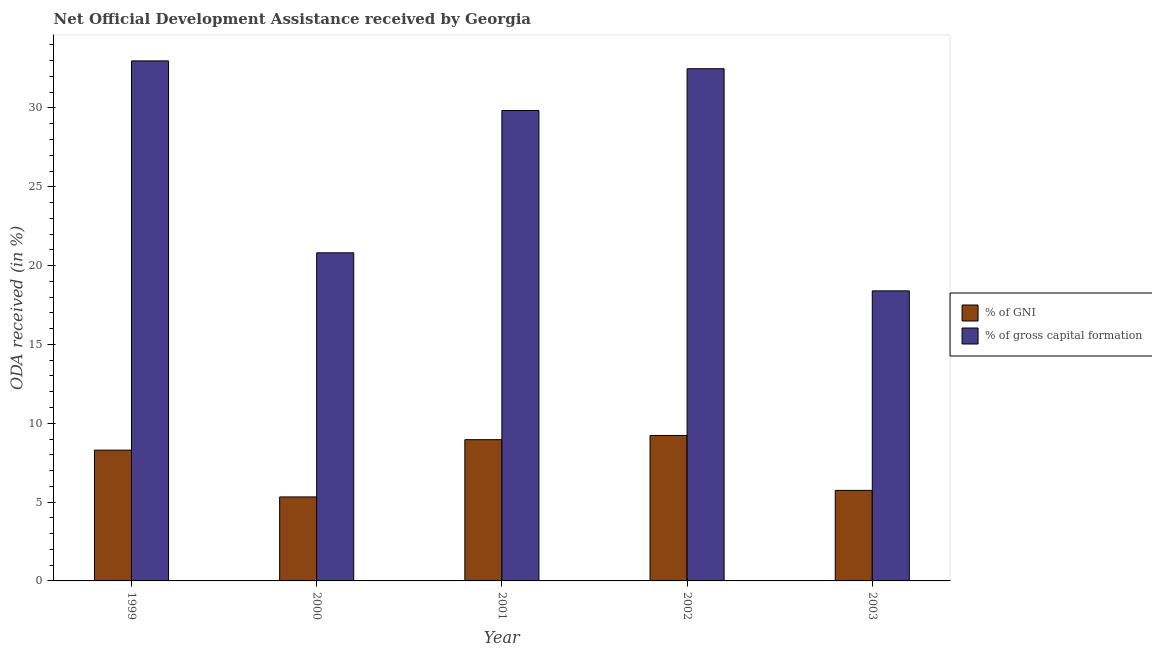How many groups of bars are there?
Provide a succinct answer. 5. Are the number of bars per tick equal to the number of legend labels?
Provide a short and direct response. Yes. How many bars are there on the 3rd tick from the left?
Your answer should be compact. 2. What is the oda received as percentage of gross capital formation in 1999?
Give a very brief answer. 32.99. Across all years, what is the maximum oda received as percentage of gni?
Offer a terse response. 9.23. Across all years, what is the minimum oda received as percentage of gni?
Make the answer very short. 5.33. In which year was the oda received as percentage of gni maximum?
Your response must be concise. 2002. What is the total oda received as percentage of gni in the graph?
Offer a very short reply. 37.55. What is the difference between the oda received as percentage of gross capital formation in 1999 and that in 2001?
Give a very brief answer. 3.15. What is the difference between the oda received as percentage of gni in 2001 and the oda received as percentage of gross capital formation in 1999?
Give a very brief answer. 0.66. What is the average oda received as percentage of gross capital formation per year?
Make the answer very short. 26.91. In the year 2003, what is the difference between the oda received as percentage of gross capital formation and oda received as percentage of gni?
Provide a short and direct response. 0. What is the ratio of the oda received as percentage of gross capital formation in 1999 to that in 2000?
Your answer should be very brief. 1.58. Is the oda received as percentage of gni in 1999 less than that in 2001?
Give a very brief answer. Yes. What is the difference between the highest and the second highest oda received as percentage of gni?
Your response must be concise. 0.27. What is the difference between the highest and the lowest oda received as percentage of gni?
Provide a short and direct response. 3.9. What does the 2nd bar from the left in 2001 represents?
Keep it short and to the point. % of gross capital formation. What does the 2nd bar from the right in 2003 represents?
Your response must be concise. % of GNI. What is the difference between two consecutive major ticks on the Y-axis?
Make the answer very short. 5. Are the values on the major ticks of Y-axis written in scientific E-notation?
Give a very brief answer. No. Does the graph contain any zero values?
Offer a very short reply. No. Does the graph contain grids?
Keep it short and to the point. No. Where does the legend appear in the graph?
Your answer should be very brief. Center right. How many legend labels are there?
Provide a succinct answer. 2. How are the legend labels stacked?
Keep it short and to the point. Vertical. What is the title of the graph?
Offer a very short reply. Net Official Development Assistance received by Georgia. Does "Excluding technical cooperation" appear as one of the legend labels in the graph?
Make the answer very short. No. What is the label or title of the Y-axis?
Keep it short and to the point. ODA received (in %). What is the ODA received (in %) of % of GNI in 1999?
Your response must be concise. 8.3. What is the ODA received (in %) of % of gross capital formation in 1999?
Ensure brevity in your answer.  32.99. What is the ODA received (in %) in % of GNI in 2000?
Your answer should be very brief. 5.33. What is the ODA received (in %) of % of gross capital formation in 2000?
Provide a short and direct response. 20.81. What is the ODA received (in %) of % of GNI in 2001?
Your answer should be very brief. 8.96. What is the ODA received (in %) of % of gross capital formation in 2001?
Provide a succinct answer. 29.84. What is the ODA received (in %) in % of GNI in 2002?
Offer a very short reply. 9.23. What is the ODA received (in %) of % of gross capital formation in 2002?
Offer a terse response. 32.49. What is the ODA received (in %) in % of GNI in 2003?
Ensure brevity in your answer.  5.74. What is the ODA received (in %) of % of gross capital formation in 2003?
Keep it short and to the point. 18.4. Across all years, what is the maximum ODA received (in %) of % of GNI?
Offer a terse response. 9.23. Across all years, what is the maximum ODA received (in %) in % of gross capital formation?
Provide a succinct answer. 32.99. Across all years, what is the minimum ODA received (in %) in % of GNI?
Provide a short and direct response. 5.33. Across all years, what is the minimum ODA received (in %) of % of gross capital formation?
Give a very brief answer. 18.4. What is the total ODA received (in %) in % of GNI in the graph?
Keep it short and to the point. 37.55. What is the total ODA received (in %) of % of gross capital formation in the graph?
Keep it short and to the point. 134.53. What is the difference between the ODA received (in %) in % of GNI in 1999 and that in 2000?
Provide a short and direct response. 2.97. What is the difference between the ODA received (in %) of % of gross capital formation in 1999 and that in 2000?
Your response must be concise. 12.18. What is the difference between the ODA received (in %) of % of GNI in 1999 and that in 2001?
Offer a very short reply. -0.66. What is the difference between the ODA received (in %) of % of gross capital formation in 1999 and that in 2001?
Offer a very short reply. 3.15. What is the difference between the ODA received (in %) in % of GNI in 1999 and that in 2002?
Your response must be concise. -0.93. What is the difference between the ODA received (in %) in % of gross capital formation in 1999 and that in 2002?
Your response must be concise. 0.5. What is the difference between the ODA received (in %) in % of GNI in 1999 and that in 2003?
Ensure brevity in your answer.  2.55. What is the difference between the ODA received (in %) of % of gross capital formation in 1999 and that in 2003?
Give a very brief answer. 14.59. What is the difference between the ODA received (in %) in % of GNI in 2000 and that in 2001?
Offer a terse response. -3.63. What is the difference between the ODA received (in %) in % of gross capital formation in 2000 and that in 2001?
Offer a terse response. -9.03. What is the difference between the ODA received (in %) of % of GNI in 2000 and that in 2002?
Provide a succinct answer. -3.9. What is the difference between the ODA received (in %) of % of gross capital formation in 2000 and that in 2002?
Your answer should be very brief. -11.68. What is the difference between the ODA received (in %) in % of GNI in 2000 and that in 2003?
Keep it short and to the point. -0.42. What is the difference between the ODA received (in %) in % of gross capital formation in 2000 and that in 2003?
Your response must be concise. 2.41. What is the difference between the ODA received (in %) of % of GNI in 2001 and that in 2002?
Ensure brevity in your answer.  -0.27. What is the difference between the ODA received (in %) of % of gross capital formation in 2001 and that in 2002?
Provide a short and direct response. -2.65. What is the difference between the ODA received (in %) in % of GNI in 2001 and that in 2003?
Provide a succinct answer. 3.22. What is the difference between the ODA received (in %) of % of gross capital formation in 2001 and that in 2003?
Your response must be concise. 11.44. What is the difference between the ODA received (in %) of % of GNI in 2002 and that in 2003?
Offer a terse response. 3.48. What is the difference between the ODA received (in %) of % of gross capital formation in 2002 and that in 2003?
Make the answer very short. 14.09. What is the difference between the ODA received (in %) in % of GNI in 1999 and the ODA received (in %) in % of gross capital formation in 2000?
Keep it short and to the point. -12.52. What is the difference between the ODA received (in %) of % of GNI in 1999 and the ODA received (in %) of % of gross capital formation in 2001?
Make the answer very short. -21.54. What is the difference between the ODA received (in %) of % of GNI in 1999 and the ODA received (in %) of % of gross capital formation in 2002?
Your answer should be compact. -24.19. What is the difference between the ODA received (in %) of % of GNI in 1999 and the ODA received (in %) of % of gross capital formation in 2003?
Ensure brevity in your answer.  -10.1. What is the difference between the ODA received (in %) in % of GNI in 2000 and the ODA received (in %) in % of gross capital formation in 2001?
Keep it short and to the point. -24.51. What is the difference between the ODA received (in %) of % of GNI in 2000 and the ODA received (in %) of % of gross capital formation in 2002?
Your answer should be very brief. -27.16. What is the difference between the ODA received (in %) of % of GNI in 2000 and the ODA received (in %) of % of gross capital formation in 2003?
Your answer should be very brief. -13.07. What is the difference between the ODA received (in %) of % of GNI in 2001 and the ODA received (in %) of % of gross capital formation in 2002?
Give a very brief answer. -23.53. What is the difference between the ODA received (in %) in % of GNI in 2001 and the ODA received (in %) in % of gross capital formation in 2003?
Your response must be concise. -9.44. What is the difference between the ODA received (in %) of % of GNI in 2002 and the ODA received (in %) of % of gross capital formation in 2003?
Offer a very short reply. -9.17. What is the average ODA received (in %) in % of GNI per year?
Give a very brief answer. 7.51. What is the average ODA received (in %) of % of gross capital formation per year?
Make the answer very short. 26.91. In the year 1999, what is the difference between the ODA received (in %) of % of GNI and ODA received (in %) of % of gross capital formation?
Offer a very short reply. -24.69. In the year 2000, what is the difference between the ODA received (in %) of % of GNI and ODA received (in %) of % of gross capital formation?
Make the answer very short. -15.48. In the year 2001, what is the difference between the ODA received (in %) in % of GNI and ODA received (in %) in % of gross capital formation?
Offer a very short reply. -20.88. In the year 2002, what is the difference between the ODA received (in %) in % of GNI and ODA received (in %) in % of gross capital formation?
Your answer should be very brief. -23.26. In the year 2003, what is the difference between the ODA received (in %) in % of GNI and ODA received (in %) in % of gross capital formation?
Your answer should be very brief. -12.66. What is the ratio of the ODA received (in %) in % of GNI in 1999 to that in 2000?
Offer a terse response. 1.56. What is the ratio of the ODA received (in %) in % of gross capital formation in 1999 to that in 2000?
Make the answer very short. 1.58. What is the ratio of the ODA received (in %) of % of GNI in 1999 to that in 2001?
Your response must be concise. 0.93. What is the ratio of the ODA received (in %) of % of gross capital formation in 1999 to that in 2001?
Provide a short and direct response. 1.11. What is the ratio of the ODA received (in %) of % of GNI in 1999 to that in 2002?
Make the answer very short. 0.9. What is the ratio of the ODA received (in %) of % of gross capital formation in 1999 to that in 2002?
Provide a succinct answer. 1.02. What is the ratio of the ODA received (in %) in % of GNI in 1999 to that in 2003?
Ensure brevity in your answer.  1.44. What is the ratio of the ODA received (in %) in % of gross capital formation in 1999 to that in 2003?
Offer a terse response. 1.79. What is the ratio of the ODA received (in %) of % of GNI in 2000 to that in 2001?
Keep it short and to the point. 0.59. What is the ratio of the ODA received (in %) in % of gross capital formation in 2000 to that in 2001?
Offer a very short reply. 0.7. What is the ratio of the ODA received (in %) of % of GNI in 2000 to that in 2002?
Provide a short and direct response. 0.58. What is the ratio of the ODA received (in %) of % of gross capital formation in 2000 to that in 2002?
Offer a very short reply. 0.64. What is the ratio of the ODA received (in %) of % of GNI in 2000 to that in 2003?
Your answer should be very brief. 0.93. What is the ratio of the ODA received (in %) in % of gross capital formation in 2000 to that in 2003?
Your response must be concise. 1.13. What is the ratio of the ODA received (in %) of % of GNI in 2001 to that in 2002?
Make the answer very short. 0.97. What is the ratio of the ODA received (in %) in % of gross capital formation in 2001 to that in 2002?
Keep it short and to the point. 0.92. What is the ratio of the ODA received (in %) of % of GNI in 2001 to that in 2003?
Provide a succinct answer. 1.56. What is the ratio of the ODA received (in %) in % of gross capital formation in 2001 to that in 2003?
Give a very brief answer. 1.62. What is the ratio of the ODA received (in %) in % of GNI in 2002 to that in 2003?
Make the answer very short. 1.61. What is the ratio of the ODA received (in %) of % of gross capital formation in 2002 to that in 2003?
Provide a short and direct response. 1.77. What is the difference between the highest and the second highest ODA received (in %) in % of GNI?
Provide a short and direct response. 0.27. What is the difference between the highest and the second highest ODA received (in %) of % of gross capital formation?
Your answer should be compact. 0.5. What is the difference between the highest and the lowest ODA received (in %) of % of GNI?
Provide a succinct answer. 3.9. What is the difference between the highest and the lowest ODA received (in %) in % of gross capital formation?
Your answer should be compact. 14.59. 